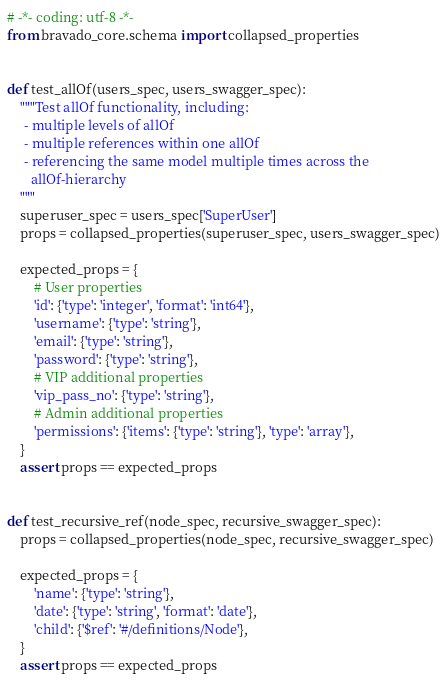Convert code to text. <code><loc_0><loc_0><loc_500><loc_500><_Python_># -*- coding: utf-8 -*-
from bravado_core.schema import collapsed_properties


def test_allOf(users_spec, users_swagger_spec):
    """Test allOf functionality, including:
     - multiple levels of allOf
     - multiple references within one allOf
     - referencing the same model multiple times across the
       allOf-hierarchy
    """
    superuser_spec = users_spec['SuperUser']
    props = collapsed_properties(superuser_spec, users_swagger_spec)

    expected_props = {
        # User properties
        'id': {'type': 'integer', 'format': 'int64'},
        'username': {'type': 'string'},
        'email': {'type': 'string'},
        'password': {'type': 'string'},
        # VIP additional properties
        'vip_pass_no': {'type': 'string'},
        # Admin additional properties
        'permissions': {'items': {'type': 'string'}, 'type': 'array'},
    }
    assert props == expected_props


def test_recursive_ref(node_spec, recursive_swagger_spec):
    props = collapsed_properties(node_spec, recursive_swagger_spec)

    expected_props = {
        'name': {'type': 'string'},
        'date': {'type': 'string', 'format': 'date'},
        'child': {'$ref': '#/definitions/Node'},
    }
    assert props == expected_props
</code> 